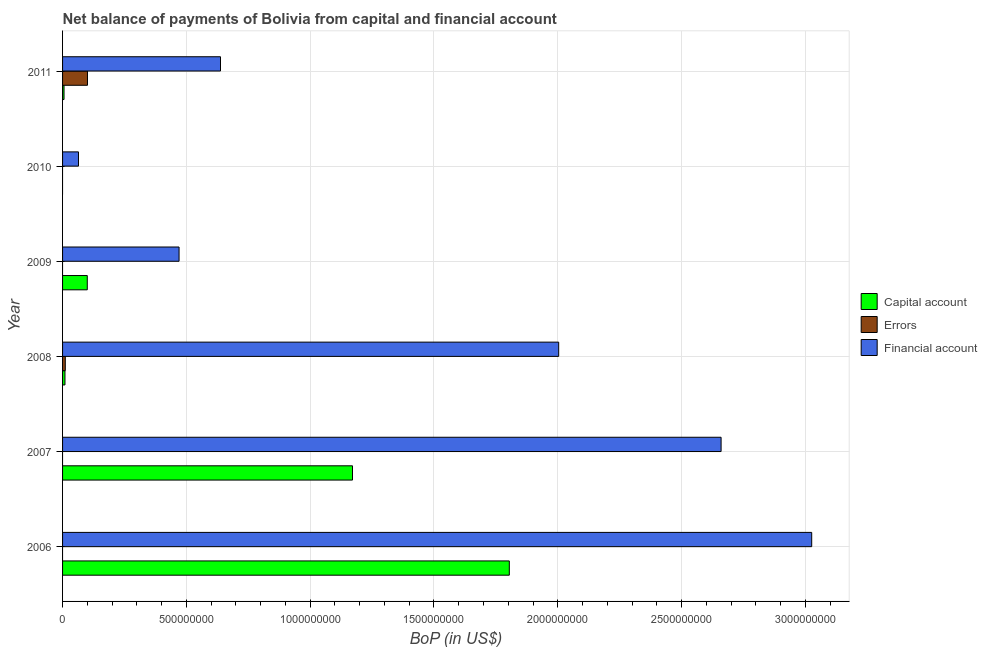How many different coloured bars are there?
Give a very brief answer. 3. Are the number of bars per tick equal to the number of legend labels?
Provide a short and direct response. No. Are the number of bars on each tick of the Y-axis equal?
Make the answer very short. No. How many bars are there on the 5th tick from the bottom?
Give a very brief answer. 1. What is the label of the 6th group of bars from the top?
Offer a terse response. 2006. What is the amount of net capital account in 2007?
Provide a short and direct response. 1.17e+09. Across all years, what is the maximum amount of net capital account?
Ensure brevity in your answer.  1.80e+09. Across all years, what is the minimum amount of financial account?
Your response must be concise. 6.43e+07. What is the total amount of net capital account in the graph?
Ensure brevity in your answer.  3.09e+09. What is the difference between the amount of financial account in 2008 and that in 2010?
Keep it short and to the point. 1.94e+09. What is the difference between the amount of financial account in 2008 and the amount of net capital account in 2011?
Your answer should be very brief. 2.00e+09. What is the average amount of errors per year?
Offer a very short reply. 1.86e+07. In the year 2009, what is the difference between the amount of net capital account and amount of financial account?
Ensure brevity in your answer.  -3.71e+08. In how many years, is the amount of net capital account greater than 2600000000 US$?
Provide a succinct answer. 0. What is the ratio of the amount of net capital account in 2009 to that in 2011?
Give a very brief answer. 16.82. What is the difference between the highest and the second highest amount of net capital account?
Make the answer very short. 6.33e+08. What is the difference between the highest and the lowest amount of net capital account?
Offer a terse response. 1.80e+09. How many bars are there?
Your answer should be very brief. 13. How many years are there in the graph?
Provide a succinct answer. 6. Are the values on the major ticks of X-axis written in scientific E-notation?
Offer a very short reply. No. Does the graph contain grids?
Keep it short and to the point. Yes. What is the title of the graph?
Your answer should be compact. Net balance of payments of Bolivia from capital and financial account. What is the label or title of the X-axis?
Provide a short and direct response. BoP (in US$). What is the BoP (in US$) in Capital account in 2006?
Make the answer very short. 1.80e+09. What is the BoP (in US$) of Errors in 2006?
Make the answer very short. 0. What is the BoP (in US$) of Financial account in 2006?
Your answer should be compact. 3.03e+09. What is the BoP (in US$) of Capital account in 2007?
Keep it short and to the point. 1.17e+09. What is the BoP (in US$) of Errors in 2007?
Make the answer very short. 0. What is the BoP (in US$) of Financial account in 2007?
Offer a very short reply. 2.66e+09. What is the BoP (in US$) in Capital account in 2008?
Provide a succinct answer. 9.70e+06. What is the BoP (in US$) in Errors in 2008?
Provide a succinct answer. 1.10e+07. What is the BoP (in US$) of Financial account in 2008?
Make the answer very short. 2.00e+09. What is the BoP (in US$) in Capital account in 2009?
Provide a succinct answer. 9.98e+07. What is the BoP (in US$) in Errors in 2009?
Your answer should be very brief. 0. What is the BoP (in US$) in Financial account in 2009?
Keep it short and to the point. 4.71e+08. What is the BoP (in US$) of Financial account in 2010?
Ensure brevity in your answer.  6.43e+07. What is the BoP (in US$) of Capital account in 2011?
Provide a short and direct response. 5.93e+06. What is the BoP (in US$) of Errors in 2011?
Your answer should be compact. 1.01e+08. What is the BoP (in US$) of Financial account in 2011?
Provide a short and direct response. 6.38e+08. Across all years, what is the maximum BoP (in US$) in Capital account?
Your response must be concise. 1.80e+09. Across all years, what is the maximum BoP (in US$) of Errors?
Make the answer very short. 1.01e+08. Across all years, what is the maximum BoP (in US$) in Financial account?
Your answer should be compact. 3.03e+09. Across all years, what is the minimum BoP (in US$) in Capital account?
Ensure brevity in your answer.  0. Across all years, what is the minimum BoP (in US$) of Errors?
Offer a very short reply. 0. Across all years, what is the minimum BoP (in US$) in Financial account?
Your answer should be compact. 6.43e+07. What is the total BoP (in US$) of Capital account in the graph?
Give a very brief answer. 3.09e+09. What is the total BoP (in US$) of Errors in the graph?
Your response must be concise. 1.12e+08. What is the total BoP (in US$) in Financial account in the graph?
Your answer should be very brief. 8.86e+09. What is the difference between the BoP (in US$) of Capital account in 2006 and that in 2007?
Keep it short and to the point. 6.33e+08. What is the difference between the BoP (in US$) of Financial account in 2006 and that in 2007?
Your answer should be very brief. 3.66e+08. What is the difference between the BoP (in US$) of Capital account in 2006 and that in 2008?
Keep it short and to the point. 1.79e+09. What is the difference between the BoP (in US$) of Financial account in 2006 and that in 2008?
Your response must be concise. 1.02e+09. What is the difference between the BoP (in US$) in Capital account in 2006 and that in 2009?
Offer a terse response. 1.70e+09. What is the difference between the BoP (in US$) in Financial account in 2006 and that in 2009?
Make the answer very short. 2.56e+09. What is the difference between the BoP (in US$) of Financial account in 2006 and that in 2010?
Make the answer very short. 2.96e+09. What is the difference between the BoP (in US$) in Capital account in 2006 and that in 2011?
Make the answer very short. 1.80e+09. What is the difference between the BoP (in US$) in Financial account in 2006 and that in 2011?
Ensure brevity in your answer.  2.39e+09. What is the difference between the BoP (in US$) of Capital account in 2007 and that in 2008?
Make the answer very short. 1.16e+09. What is the difference between the BoP (in US$) of Financial account in 2007 and that in 2008?
Your response must be concise. 6.56e+08. What is the difference between the BoP (in US$) of Capital account in 2007 and that in 2009?
Ensure brevity in your answer.  1.07e+09. What is the difference between the BoP (in US$) of Financial account in 2007 and that in 2009?
Your answer should be very brief. 2.19e+09. What is the difference between the BoP (in US$) in Financial account in 2007 and that in 2010?
Provide a short and direct response. 2.60e+09. What is the difference between the BoP (in US$) of Capital account in 2007 and that in 2011?
Give a very brief answer. 1.17e+09. What is the difference between the BoP (in US$) of Financial account in 2007 and that in 2011?
Offer a terse response. 2.02e+09. What is the difference between the BoP (in US$) in Capital account in 2008 and that in 2009?
Make the answer very short. -9.01e+07. What is the difference between the BoP (in US$) in Financial account in 2008 and that in 2009?
Your answer should be compact. 1.53e+09. What is the difference between the BoP (in US$) in Financial account in 2008 and that in 2010?
Provide a short and direct response. 1.94e+09. What is the difference between the BoP (in US$) in Capital account in 2008 and that in 2011?
Offer a terse response. 3.77e+06. What is the difference between the BoP (in US$) in Errors in 2008 and that in 2011?
Offer a very short reply. -8.96e+07. What is the difference between the BoP (in US$) of Financial account in 2008 and that in 2011?
Offer a very short reply. 1.37e+09. What is the difference between the BoP (in US$) of Financial account in 2009 and that in 2010?
Your answer should be compact. 4.06e+08. What is the difference between the BoP (in US$) in Capital account in 2009 and that in 2011?
Your response must be concise. 9.39e+07. What is the difference between the BoP (in US$) of Financial account in 2009 and that in 2011?
Give a very brief answer. -1.67e+08. What is the difference between the BoP (in US$) of Financial account in 2010 and that in 2011?
Your answer should be very brief. -5.74e+08. What is the difference between the BoP (in US$) in Capital account in 2006 and the BoP (in US$) in Financial account in 2007?
Offer a terse response. -8.55e+08. What is the difference between the BoP (in US$) of Capital account in 2006 and the BoP (in US$) of Errors in 2008?
Keep it short and to the point. 1.79e+09. What is the difference between the BoP (in US$) in Capital account in 2006 and the BoP (in US$) in Financial account in 2008?
Make the answer very short. -1.99e+08. What is the difference between the BoP (in US$) of Capital account in 2006 and the BoP (in US$) of Financial account in 2009?
Offer a terse response. 1.33e+09. What is the difference between the BoP (in US$) of Capital account in 2006 and the BoP (in US$) of Financial account in 2010?
Provide a succinct answer. 1.74e+09. What is the difference between the BoP (in US$) of Capital account in 2006 and the BoP (in US$) of Errors in 2011?
Offer a very short reply. 1.70e+09. What is the difference between the BoP (in US$) of Capital account in 2006 and the BoP (in US$) of Financial account in 2011?
Your answer should be very brief. 1.17e+09. What is the difference between the BoP (in US$) of Capital account in 2007 and the BoP (in US$) of Errors in 2008?
Give a very brief answer. 1.16e+09. What is the difference between the BoP (in US$) of Capital account in 2007 and the BoP (in US$) of Financial account in 2008?
Give a very brief answer. -8.33e+08. What is the difference between the BoP (in US$) of Capital account in 2007 and the BoP (in US$) of Financial account in 2009?
Provide a succinct answer. 7.00e+08. What is the difference between the BoP (in US$) of Capital account in 2007 and the BoP (in US$) of Financial account in 2010?
Offer a terse response. 1.11e+09. What is the difference between the BoP (in US$) of Capital account in 2007 and the BoP (in US$) of Errors in 2011?
Make the answer very short. 1.07e+09. What is the difference between the BoP (in US$) in Capital account in 2007 and the BoP (in US$) in Financial account in 2011?
Provide a short and direct response. 5.33e+08. What is the difference between the BoP (in US$) in Capital account in 2008 and the BoP (in US$) in Financial account in 2009?
Offer a very short reply. -4.61e+08. What is the difference between the BoP (in US$) of Errors in 2008 and the BoP (in US$) of Financial account in 2009?
Ensure brevity in your answer.  -4.60e+08. What is the difference between the BoP (in US$) of Capital account in 2008 and the BoP (in US$) of Financial account in 2010?
Offer a very short reply. -5.46e+07. What is the difference between the BoP (in US$) in Errors in 2008 and the BoP (in US$) in Financial account in 2010?
Provide a short and direct response. -5.33e+07. What is the difference between the BoP (in US$) in Capital account in 2008 and the BoP (in US$) in Errors in 2011?
Give a very brief answer. -9.09e+07. What is the difference between the BoP (in US$) of Capital account in 2008 and the BoP (in US$) of Financial account in 2011?
Ensure brevity in your answer.  -6.28e+08. What is the difference between the BoP (in US$) of Errors in 2008 and the BoP (in US$) of Financial account in 2011?
Ensure brevity in your answer.  -6.27e+08. What is the difference between the BoP (in US$) in Capital account in 2009 and the BoP (in US$) in Financial account in 2010?
Offer a terse response. 3.55e+07. What is the difference between the BoP (in US$) of Capital account in 2009 and the BoP (in US$) of Errors in 2011?
Give a very brief answer. -8.39e+05. What is the difference between the BoP (in US$) of Capital account in 2009 and the BoP (in US$) of Financial account in 2011?
Your response must be concise. -5.38e+08. What is the average BoP (in US$) of Capital account per year?
Your answer should be very brief. 5.15e+08. What is the average BoP (in US$) of Errors per year?
Provide a succinct answer. 1.86e+07. What is the average BoP (in US$) in Financial account per year?
Provide a short and direct response. 1.48e+09. In the year 2006, what is the difference between the BoP (in US$) in Capital account and BoP (in US$) in Financial account?
Your answer should be compact. -1.22e+09. In the year 2007, what is the difference between the BoP (in US$) in Capital account and BoP (in US$) in Financial account?
Provide a succinct answer. -1.49e+09. In the year 2008, what is the difference between the BoP (in US$) in Capital account and BoP (in US$) in Errors?
Your answer should be very brief. -1.31e+06. In the year 2008, what is the difference between the BoP (in US$) in Capital account and BoP (in US$) in Financial account?
Ensure brevity in your answer.  -1.99e+09. In the year 2008, what is the difference between the BoP (in US$) of Errors and BoP (in US$) of Financial account?
Offer a very short reply. -1.99e+09. In the year 2009, what is the difference between the BoP (in US$) in Capital account and BoP (in US$) in Financial account?
Offer a terse response. -3.71e+08. In the year 2011, what is the difference between the BoP (in US$) of Capital account and BoP (in US$) of Errors?
Give a very brief answer. -9.47e+07. In the year 2011, what is the difference between the BoP (in US$) in Capital account and BoP (in US$) in Financial account?
Make the answer very short. -6.32e+08. In the year 2011, what is the difference between the BoP (in US$) in Errors and BoP (in US$) in Financial account?
Provide a short and direct response. -5.37e+08. What is the ratio of the BoP (in US$) in Capital account in 2006 to that in 2007?
Provide a succinct answer. 1.54. What is the ratio of the BoP (in US$) of Financial account in 2006 to that in 2007?
Your answer should be compact. 1.14. What is the ratio of the BoP (in US$) of Capital account in 2006 to that in 2008?
Ensure brevity in your answer.  185.93. What is the ratio of the BoP (in US$) of Financial account in 2006 to that in 2008?
Provide a succinct answer. 1.51. What is the ratio of the BoP (in US$) in Capital account in 2006 to that in 2009?
Your answer should be compact. 18.08. What is the ratio of the BoP (in US$) in Financial account in 2006 to that in 2009?
Give a very brief answer. 6.43. What is the ratio of the BoP (in US$) in Financial account in 2006 to that in 2010?
Make the answer very short. 47.07. What is the ratio of the BoP (in US$) in Capital account in 2006 to that in 2011?
Your response must be concise. 304.12. What is the ratio of the BoP (in US$) of Financial account in 2006 to that in 2011?
Your answer should be very brief. 4.74. What is the ratio of the BoP (in US$) in Capital account in 2007 to that in 2008?
Offer a terse response. 120.67. What is the ratio of the BoP (in US$) in Financial account in 2007 to that in 2008?
Offer a terse response. 1.33. What is the ratio of the BoP (in US$) of Capital account in 2007 to that in 2009?
Your answer should be very brief. 11.73. What is the ratio of the BoP (in US$) in Financial account in 2007 to that in 2009?
Your response must be concise. 5.65. What is the ratio of the BoP (in US$) of Financial account in 2007 to that in 2010?
Ensure brevity in your answer.  41.38. What is the ratio of the BoP (in US$) in Capital account in 2007 to that in 2011?
Offer a terse response. 197.38. What is the ratio of the BoP (in US$) of Financial account in 2007 to that in 2011?
Provide a short and direct response. 4.17. What is the ratio of the BoP (in US$) of Capital account in 2008 to that in 2009?
Your answer should be compact. 0.1. What is the ratio of the BoP (in US$) of Financial account in 2008 to that in 2009?
Provide a short and direct response. 4.26. What is the ratio of the BoP (in US$) in Financial account in 2008 to that in 2010?
Your response must be concise. 31.17. What is the ratio of the BoP (in US$) in Capital account in 2008 to that in 2011?
Keep it short and to the point. 1.64. What is the ratio of the BoP (in US$) in Errors in 2008 to that in 2011?
Your answer should be compact. 0.11. What is the ratio of the BoP (in US$) of Financial account in 2008 to that in 2011?
Make the answer very short. 3.14. What is the ratio of the BoP (in US$) in Financial account in 2009 to that in 2010?
Provide a succinct answer. 7.32. What is the ratio of the BoP (in US$) of Capital account in 2009 to that in 2011?
Offer a terse response. 16.82. What is the ratio of the BoP (in US$) in Financial account in 2009 to that in 2011?
Keep it short and to the point. 0.74. What is the ratio of the BoP (in US$) in Financial account in 2010 to that in 2011?
Your answer should be very brief. 0.1. What is the difference between the highest and the second highest BoP (in US$) in Capital account?
Give a very brief answer. 6.33e+08. What is the difference between the highest and the second highest BoP (in US$) in Financial account?
Keep it short and to the point. 3.66e+08. What is the difference between the highest and the lowest BoP (in US$) in Capital account?
Your answer should be compact. 1.80e+09. What is the difference between the highest and the lowest BoP (in US$) of Errors?
Keep it short and to the point. 1.01e+08. What is the difference between the highest and the lowest BoP (in US$) in Financial account?
Ensure brevity in your answer.  2.96e+09. 